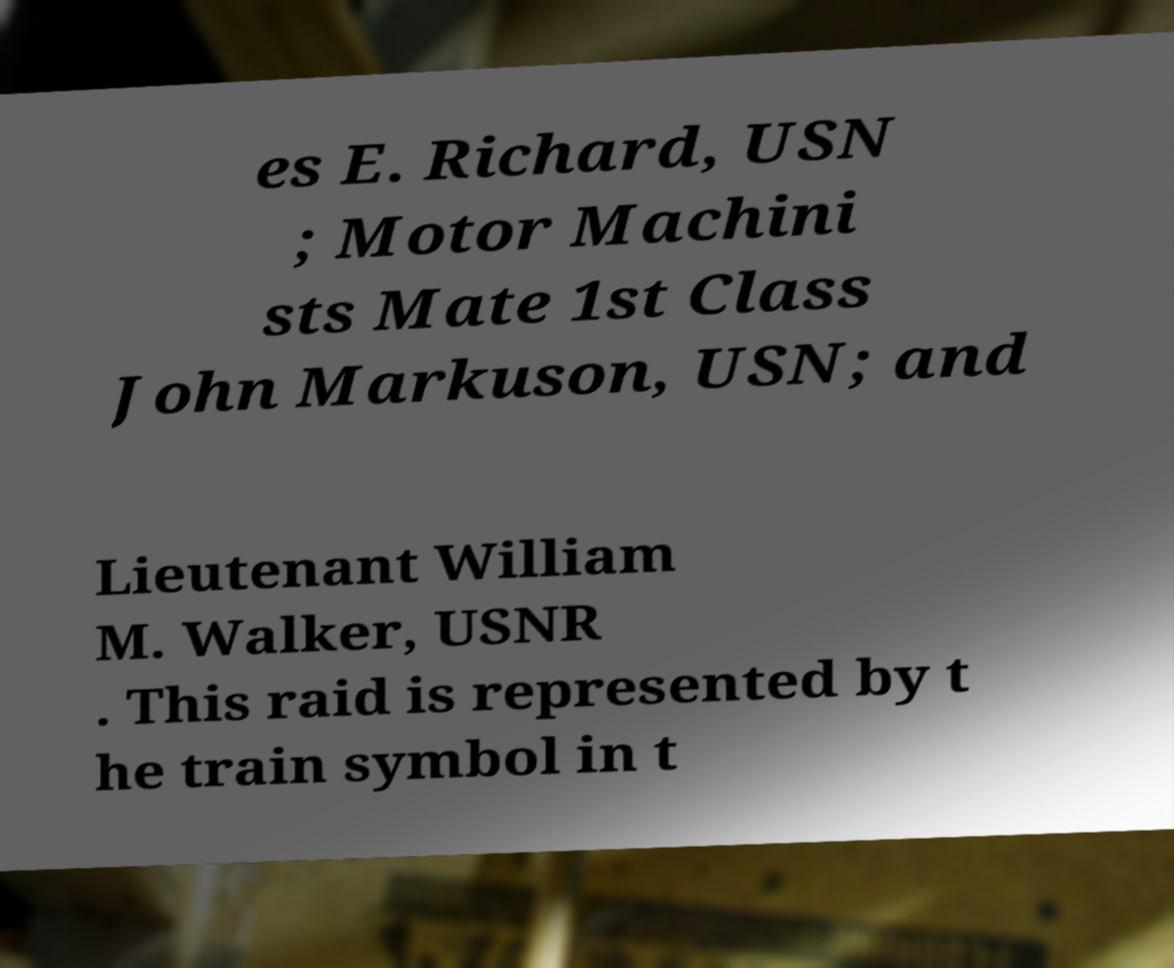Please read and relay the text visible in this image. What does it say? es E. Richard, USN ; Motor Machini sts Mate 1st Class John Markuson, USN; and Lieutenant William M. Walker, USNR . This raid is represented by t he train symbol in t 